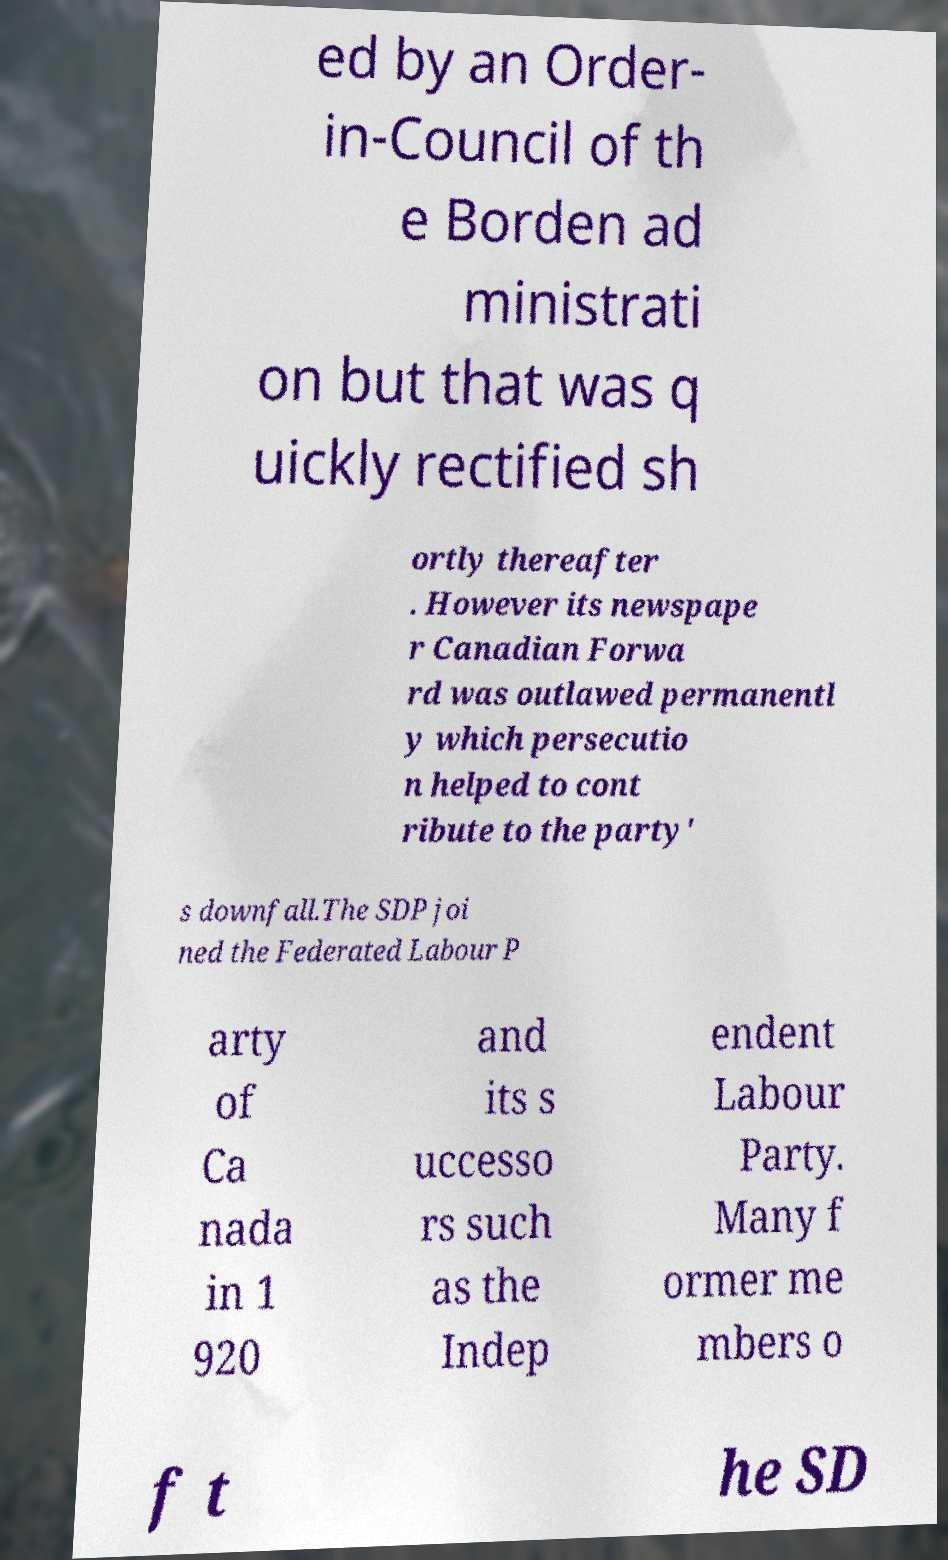For documentation purposes, I need the text within this image transcribed. Could you provide that? ed by an Order- in-Council of th e Borden ad ministrati on but that was q uickly rectified sh ortly thereafter . However its newspape r Canadian Forwa rd was outlawed permanentl y which persecutio n helped to cont ribute to the party' s downfall.The SDP joi ned the Federated Labour P arty of Ca nada in 1 920 and its s uccesso rs such as the Indep endent Labour Party. Many f ormer me mbers o f t he SD 